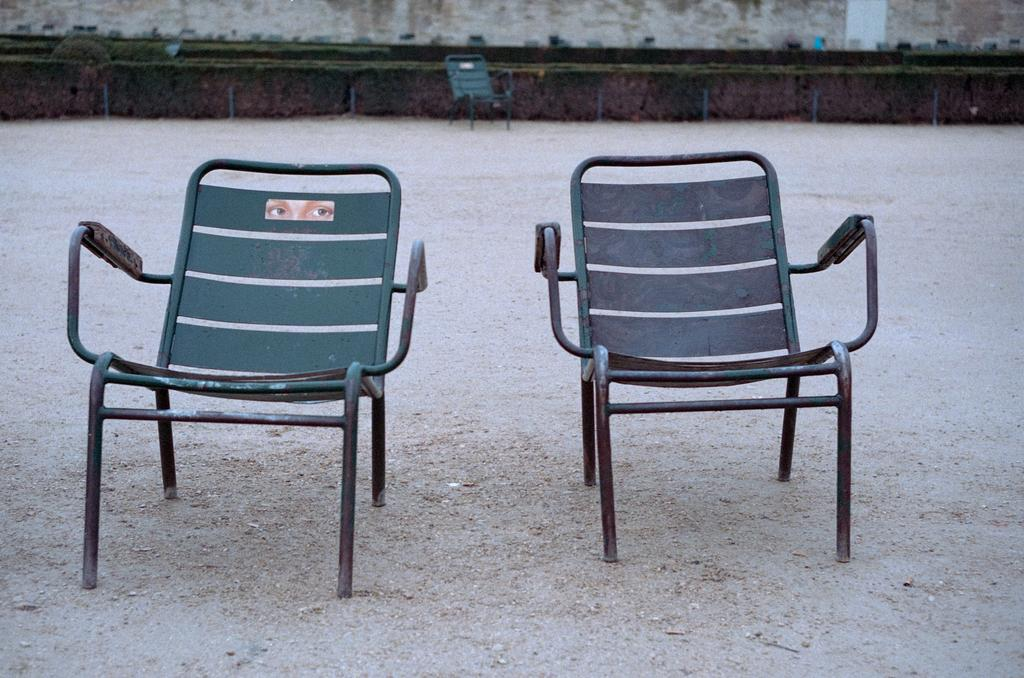How many chairs are visible in the image? There are two chairs in the image. What color are the chairs? The chairs are green in color. Are there any other chairs visible in the image? Yes, there is another chair visible in the background. What can be seen in the background of the image? There is grass and trees in the background of the image. What color are the grass and trees? The grass and trees are green in color. What type of lettuce is being used as a board in the image? There is no lettuce or board present in the image. 